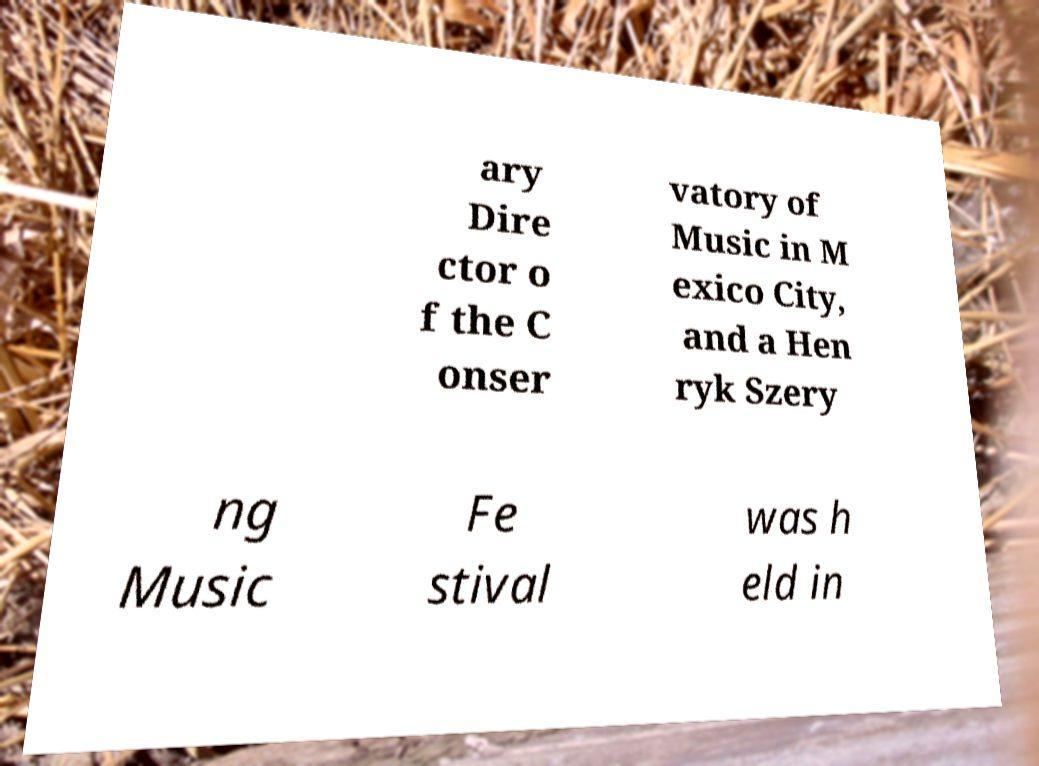Can you accurately transcribe the text from the provided image for me? ary Dire ctor o f the C onser vatory of Music in M exico City, and a Hen ryk Szery ng Music Fe stival was h eld in 